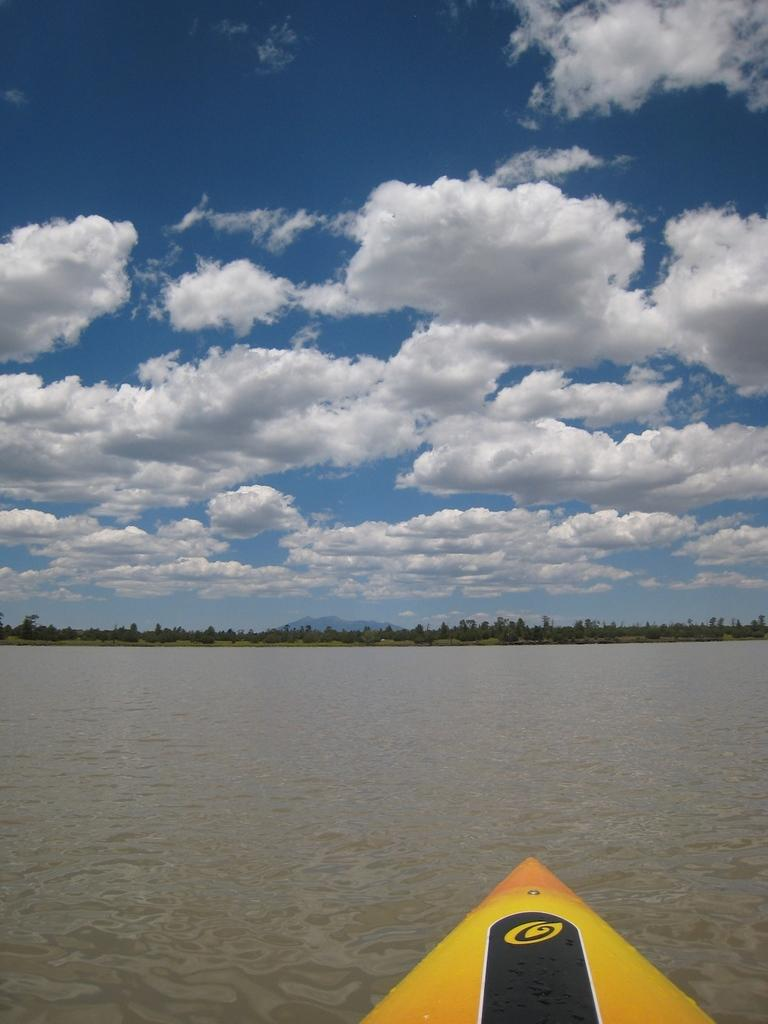What is the primary element present in the image? There is water in the image. What type of vegetation can be seen in the image? There are trees in the image. Is there any man-made object visible in the image? Yes, there appears to be a boat in the image. How would you describe the weather in the image? The sky is cloudy in the image. What type of scissors can be seen cutting the ray in the image? There are no scissors or rays present in the image. What type of oatmeal is being served on the boat in the image? There is no oatmeal or boat serving food in the image. 